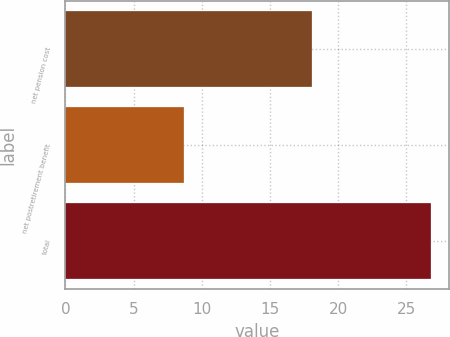<chart> <loc_0><loc_0><loc_500><loc_500><bar_chart><fcel>net pension cost<fcel>net postretirement benefit<fcel>total<nl><fcel>18.1<fcel>8.7<fcel>26.8<nl></chart> 